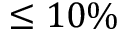<formula> <loc_0><loc_0><loc_500><loc_500>\leq 1 0 \%</formula> 